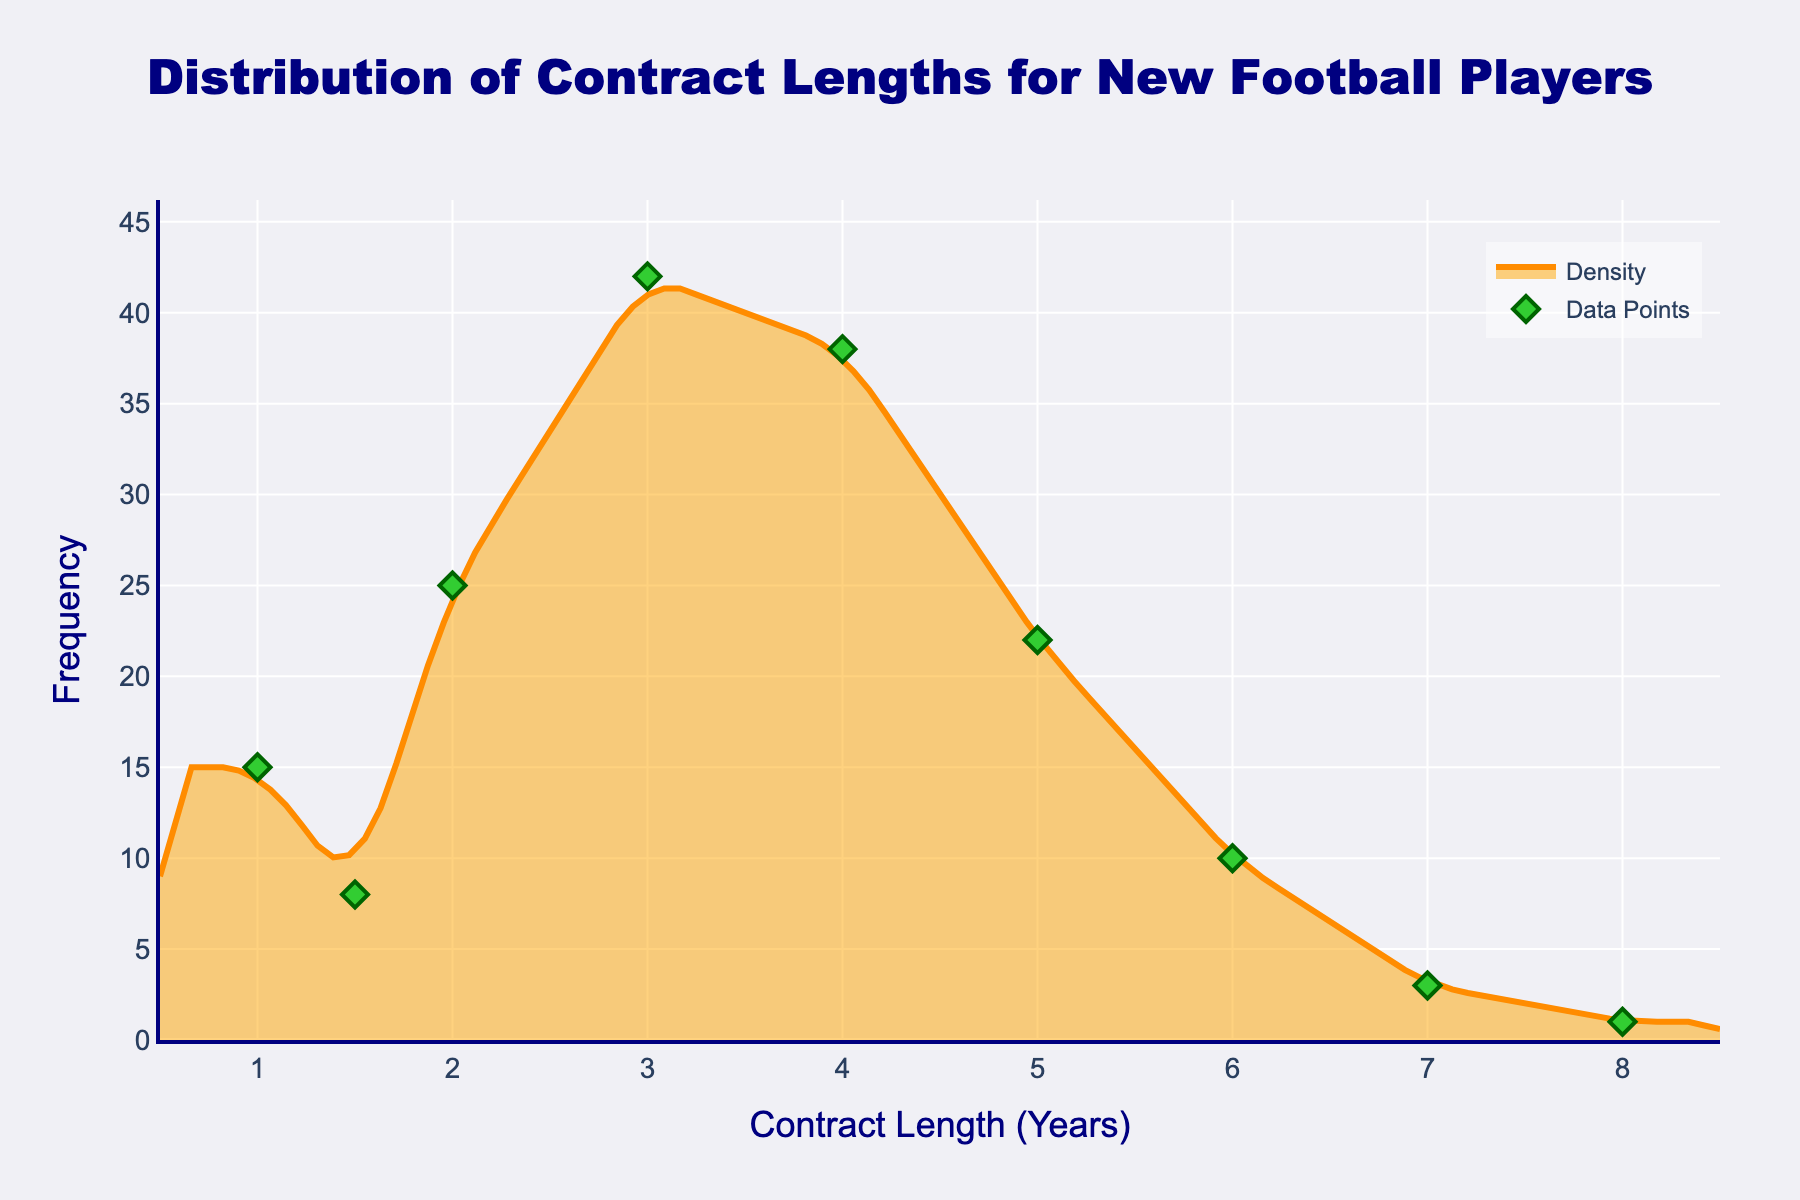What is the title of the figure? The title of the figure is prominently displayed at the top of the plot, providing a clear description of what the plot represents.
Answer: Distribution of Contract Lengths for New Football Players What are the axis titles in the plot? Axis titles are clearly labeled at the borders of the plot. The x-axis represents the contract length in years, and the y-axis represents the frequency.
Answer: Contract Length (Years), Frequency How many unique contract lengths are shown as data points in the plot? By counting the green diamond markers on the plot, we see each marker represents a unique contract length.
Answer: 9 Which contract length has the highest frequency? By looking at the peak of the density curve, the highest point represents the most frequent contract length.
Answer: 3 years What is the frequency of contracts that last for 5 years? Find the green diamond marker at the x-axis value of 5 years and read the corresponding y-axis value.
Answer: 22 What is the difference in frequency between contracts of 3 years and 6 years? Subtract the frequency of 6-year contracts (10) from the frequency of 3-year contracts (42).
Answer: 32 What is the average frequency of contracts lasting 1 year, 2 years, and 4 years? Sum the frequencies of these contract lengths (15 + 25 + 38) and divide by the number of points (3).
Answer: 26 Are there more contracts lasting less than 3 years or more than 3 years? Compare the sum of frequencies for contract lengths less than 3 years (15+8+25) with those more than 3 years (38+22+10+3+1). Less than 3 years sum to 48, more than 3 years sum to 74.
Answer: More than 3 years How does the general trend of the density plot change as the contract length increases? Observe the overall shape of the density plot: it increases to a peak at 3 years, then generally decreases with increased contract length.
Answer: Increases, then decreases What does the filled region under the density curve represent? The filled orange region under the density curve visually represents the distribution and frequency of contracts across different lengths.
Answer: Distribution and Frequency 